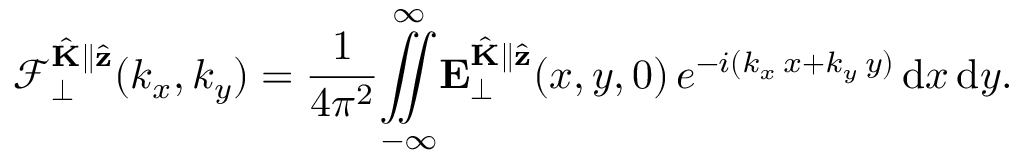Convert formula to latex. <formula><loc_0><loc_0><loc_500><loc_500>\mathcal { F } _ { \perp } ^ { \hat { K } \| \hat { z } } ( k _ { x } , k _ { y } ) = \frac { 1 } { 4 \pi ^ { 2 } } \overset { \infty } { \underset { - \infty } { \iint } } E _ { \perp } ^ { \hat { K } \| \hat { z } } ( x , y , 0 ) \, e ^ { - i ( k _ { x } \, x + k _ { y } \, y ) } \, d x \, d y .</formula> 